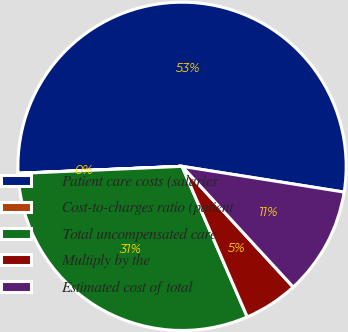Convert chart to OTSL. <chart><loc_0><loc_0><loc_500><loc_500><pie_chart><fcel>Patient care costs (salaries<fcel>Cost-to-charges ratio (patient<fcel>Total uncompensated care<fcel>Multiply by the<fcel>Estimated cost of total<nl><fcel>53.18%<fcel>0.02%<fcel>30.81%<fcel>5.34%<fcel>10.65%<nl></chart> 